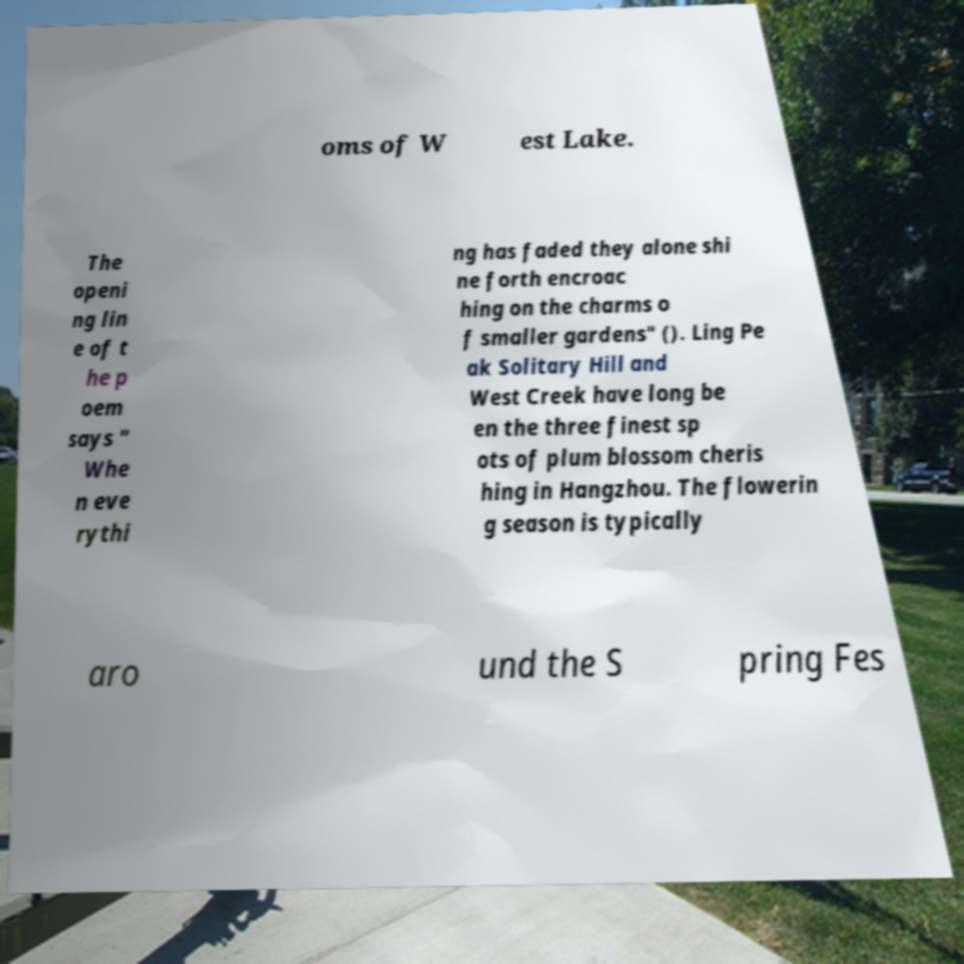Please identify and transcribe the text found in this image. oms of W est Lake. The openi ng lin e of t he p oem says " Whe n eve rythi ng has faded they alone shi ne forth encroac hing on the charms o f smaller gardens" (). Ling Pe ak Solitary Hill and West Creek have long be en the three finest sp ots of plum blossom cheris hing in Hangzhou. The flowerin g season is typically aro und the S pring Fes 